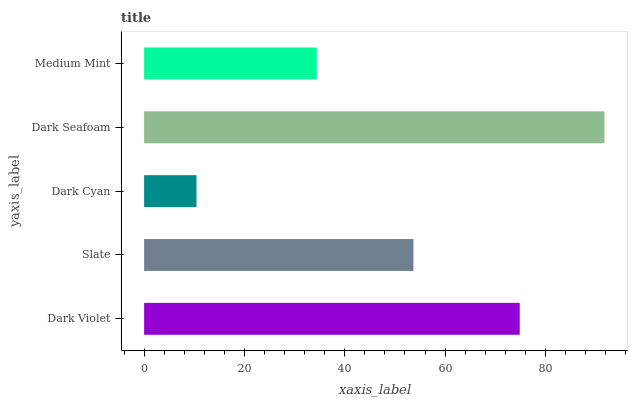Is Dark Cyan the minimum?
Answer yes or no. Yes. Is Dark Seafoam the maximum?
Answer yes or no. Yes. Is Slate the minimum?
Answer yes or no. No. Is Slate the maximum?
Answer yes or no. No. Is Dark Violet greater than Slate?
Answer yes or no. Yes. Is Slate less than Dark Violet?
Answer yes or no. Yes. Is Slate greater than Dark Violet?
Answer yes or no. No. Is Dark Violet less than Slate?
Answer yes or no. No. Is Slate the high median?
Answer yes or no. Yes. Is Slate the low median?
Answer yes or no. Yes. Is Dark Violet the high median?
Answer yes or no. No. Is Medium Mint the low median?
Answer yes or no. No. 